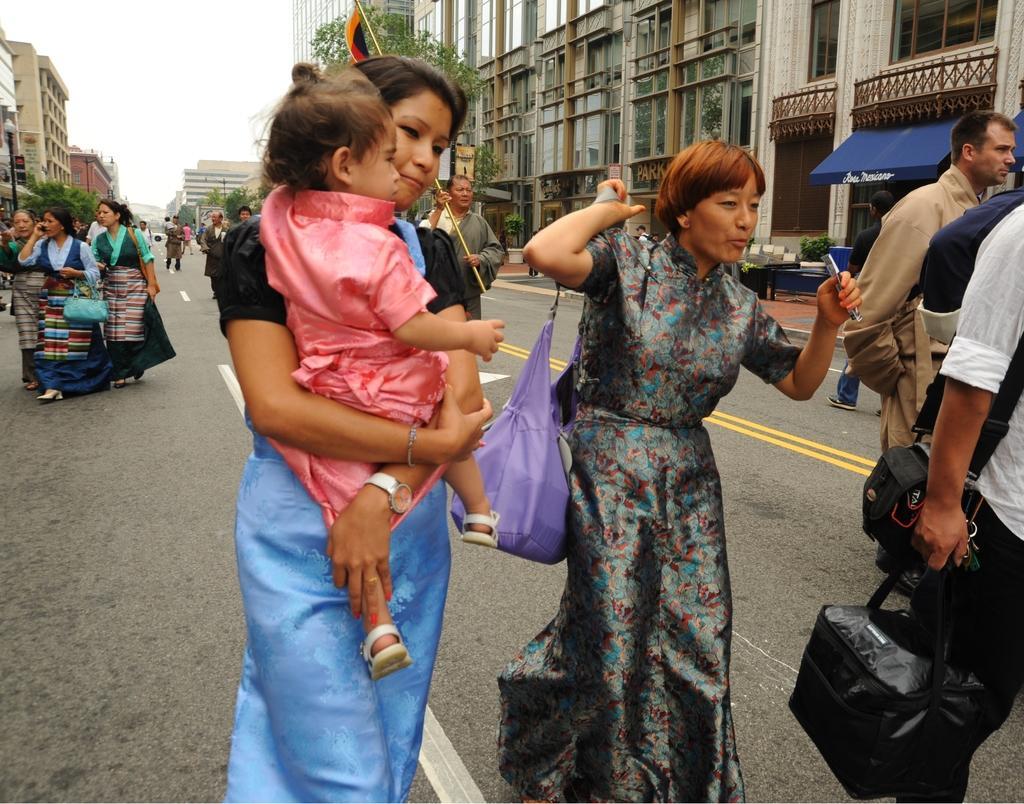In one or two sentences, can you explain what this image depicts? In this picture I can see people on the road. I can see the buildings. I can see trees. 